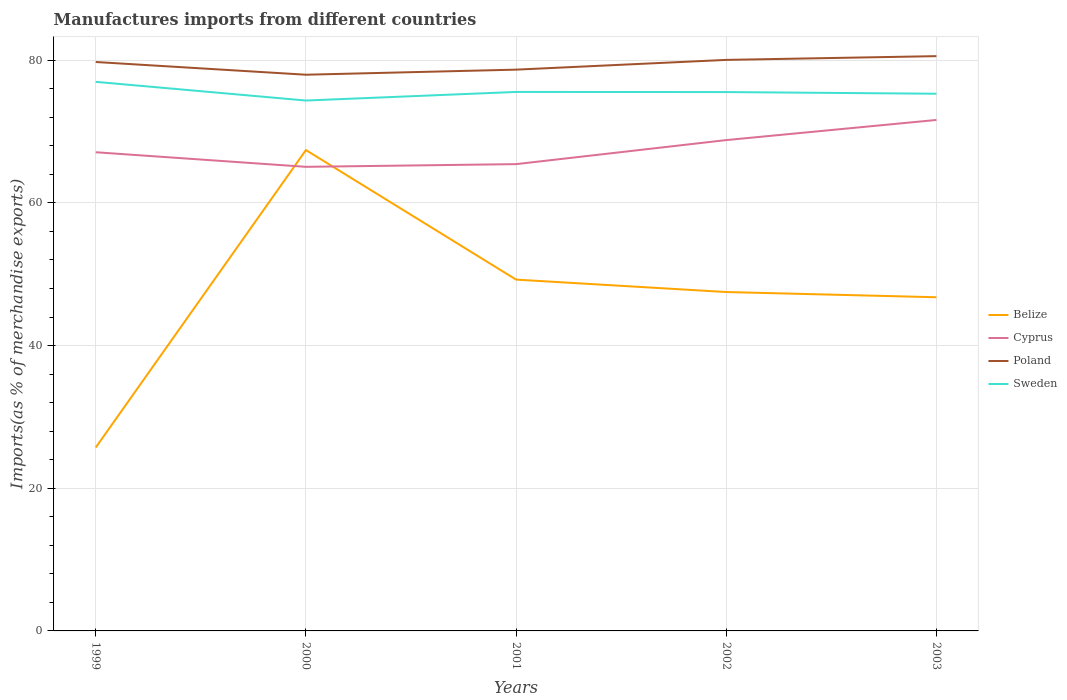Does the line corresponding to Cyprus intersect with the line corresponding to Poland?
Your response must be concise. No. Across all years, what is the maximum percentage of imports to different countries in Cyprus?
Give a very brief answer. 65.05. In which year was the percentage of imports to different countries in Belize maximum?
Your answer should be compact. 1999. What is the total percentage of imports to different countries in Cyprus in the graph?
Offer a terse response. -2.82. What is the difference between the highest and the second highest percentage of imports to different countries in Cyprus?
Your answer should be very brief. 6.57. What is the difference between the highest and the lowest percentage of imports to different countries in Belize?
Offer a very short reply. 3. Are the values on the major ticks of Y-axis written in scientific E-notation?
Make the answer very short. No. Does the graph contain any zero values?
Ensure brevity in your answer.  No. Does the graph contain grids?
Your answer should be compact. Yes. Where does the legend appear in the graph?
Provide a short and direct response. Center right. How are the legend labels stacked?
Offer a terse response. Vertical. What is the title of the graph?
Offer a very short reply. Manufactures imports from different countries. What is the label or title of the X-axis?
Your response must be concise. Years. What is the label or title of the Y-axis?
Make the answer very short. Imports(as % of merchandise exports). What is the Imports(as % of merchandise exports) in Belize in 1999?
Offer a very short reply. 25.71. What is the Imports(as % of merchandise exports) in Cyprus in 1999?
Give a very brief answer. 67.1. What is the Imports(as % of merchandise exports) in Poland in 1999?
Offer a very short reply. 79.74. What is the Imports(as % of merchandise exports) of Sweden in 1999?
Ensure brevity in your answer.  76.96. What is the Imports(as % of merchandise exports) of Belize in 2000?
Ensure brevity in your answer.  67.4. What is the Imports(as % of merchandise exports) of Cyprus in 2000?
Provide a succinct answer. 65.05. What is the Imports(as % of merchandise exports) of Poland in 2000?
Your answer should be very brief. 77.96. What is the Imports(as % of merchandise exports) of Sweden in 2000?
Your answer should be very brief. 74.34. What is the Imports(as % of merchandise exports) in Belize in 2001?
Your answer should be very brief. 49.24. What is the Imports(as % of merchandise exports) in Cyprus in 2001?
Provide a succinct answer. 65.43. What is the Imports(as % of merchandise exports) in Poland in 2001?
Ensure brevity in your answer.  78.67. What is the Imports(as % of merchandise exports) in Sweden in 2001?
Provide a succinct answer. 75.55. What is the Imports(as % of merchandise exports) of Belize in 2002?
Ensure brevity in your answer.  47.5. What is the Imports(as % of merchandise exports) in Cyprus in 2002?
Provide a short and direct response. 68.8. What is the Imports(as % of merchandise exports) of Poland in 2002?
Offer a very short reply. 80.04. What is the Imports(as % of merchandise exports) in Sweden in 2002?
Ensure brevity in your answer.  75.53. What is the Imports(as % of merchandise exports) of Belize in 2003?
Offer a very short reply. 46.77. What is the Imports(as % of merchandise exports) in Cyprus in 2003?
Provide a short and direct response. 71.62. What is the Imports(as % of merchandise exports) in Poland in 2003?
Your answer should be very brief. 80.57. What is the Imports(as % of merchandise exports) of Sweden in 2003?
Keep it short and to the point. 75.3. Across all years, what is the maximum Imports(as % of merchandise exports) in Belize?
Your response must be concise. 67.4. Across all years, what is the maximum Imports(as % of merchandise exports) of Cyprus?
Offer a terse response. 71.62. Across all years, what is the maximum Imports(as % of merchandise exports) of Poland?
Make the answer very short. 80.57. Across all years, what is the maximum Imports(as % of merchandise exports) of Sweden?
Your response must be concise. 76.96. Across all years, what is the minimum Imports(as % of merchandise exports) in Belize?
Your answer should be very brief. 25.71. Across all years, what is the minimum Imports(as % of merchandise exports) of Cyprus?
Your answer should be very brief. 65.05. Across all years, what is the minimum Imports(as % of merchandise exports) in Poland?
Provide a short and direct response. 77.96. Across all years, what is the minimum Imports(as % of merchandise exports) of Sweden?
Your response must be concise. 74.34. What is the total Imports(as % of merchandise exports) in Belize in the graph?
Your answer should be very brief. 236.63. What is the total Imports(as % of merchandise exports) of Cyprus in the graph?
Ensure brevity in your answer.  338. What is the total Imports(as % of merchandise exports) of Poland in the graph?
Your answer should be very brief. 396.98. What is the total Imports(as % of merchandise exports) in Sweden in the graph?
Offer a very short reply. 377.68. What is the difference between the Imports(as % of merchandise exports) of Belize in 1999 and that in 2000?
Provide a succinct answer. -41.69. What is the difference between the Imports(as % of merchandise exports) of Cyprus in 1999 and that in 2000?
Your response must be concise. 2.04. What is the difference between the Imports(as % of merchandise exports) of Poland in 1999 and that in 2000?
Your answer should be very brief. 1.78. What is the difference between the Imports(as % of merchandise exports) of Sweden in 1999 and that in 2000?
Offer a terse response. 2.62. What is the difference between the Imports(as % of merchandise exports) in Belize in 1999 and that in 2001?
Keep it short and to the point. -23.53. What is the difference between the Imports(as % of merchandise exports) in Cyprus in 1999 and that in 2001?
Your answer should be very brief. 1.67. What is the difference between the Imports(as % of merchandise exports) of Poland in 1999 and that in 2001?
Offer a very short reply. 1.07. What is the difference between the Imports(as % of merchandise exports) in Sweden in 1999 and that in 2001?
Offer a very short reply. 1.41. What is the difference between the Imports(as % of merchandise exports) of Belize in 1999 and that in 2002?
Make the answer very short. -21.79. What is the difference between the Imports(as % of merchandise exports) of Cyprus in 1999 and that in 2002?
Your answer should be very brief. -1.7. What is the difference between the Imports(as % of merchandise exports) in Poland in 1999 and that in 2002?
Give a very brief answer. -0.3. What is the difference between the Imports(as % of merchandise exports) in Sweden in 1999 and that in 2002?
Your response must be concise. 1.43. What is the difference between the Imports(as % of merchandise exports) in Belize in 1999 and that in 2003?
Ensure brevity in your answer.  -21.06. What is the difference between the Imports(as % of merchandise exports) in Cyprus in 1999 and that in 2003?
Your answer should be compact. -4.53. What is the difference between the Imports(as % of merchandise exports) of Poland in 1999 and that in 2003?
Your answer should be very brief. -0.82. What is the difference between the Imports(as % of merchandise exports) in Sweden in 1999 and that in 2003?
Make the answer very short. 1.67. What is the difference between the Imports(as % of merchandise exports) of Belize in 2000 and that in 2001?
Your response must be concise. 18.16. What is the difference between the Imports(as % of merchandise exports) of Cyprus in 2000 and that in 2001?
Offer a very short reply. -0.38. What is the difference between the Imports(as % of merchandise exports) in Poland in 2000 and that in 2001?
Your answer should be compact. -0.71. What is the difference between the Imports(as % of merchandise exports) in Sweden in 2000 and that in 2001?
Provide a succinct answer. -1.21. What is the difference between the Imports(as % of merchandise exports) in Belize in 2000 and that in 2002?
Your answer should be very brief. 19.9. What is the difference between the Imports(as % of merchandise exports) of Cyprus in 2000 and that in 2002?
Offer a very short reply. -3.75. What is the difference between the Imports(as % of merchandise exports) of Poland in 2000 and that in 2002?
Keep it short and to the point. -2.08. What is the difference between the Imports(as % of merchandise exports) in Sweden in 2000 and that in 2002?
Provide a short and direct response. -1.19. What is the difference between the Imports(as % of merchandise exports) in Belize in 2000 and that in 2003?
Give a very brief answer. 20.63. What is the difference between the Imports(as % of merchandise exports) in Cyprus in 2000 and that in 2003?
Ensure brevity in your answer.  -6.57. What is the difference between the Imports(as % of merchandise exports) in Poland in 2000 and that in 2003?
Give a very brief answer. -2.6. What is the difference between the Imports(as % of merchandise exports) of Sweden in 2000 and that in 2003?
Your answer should be very brief. -0.95. What is the difference between the Imports(as % of merchandise exports) in Belize in 2001 and that in 2002?
Ensure brevity in your answer.  1.74. What is the difference between the Imports(as % of merchandise exports) in Cyprus in 2001 and that in 2002?
Provide a short and direct response. -3.37. What is the difference between the Imports(as % of merchandise exports) in Poland in 2001 and that in 2002?
Keep it short and to the point. -1.37. What is the difference between the Imports(as % of merchandise exports) of Sweden in 2001 and that in 2002?
Provide a succinct answer. 0.02. What is the difference between the Imports(as % of merchandise exports) in Belize in 2001 and that in 2003?
Keep it short and to the point. 2.47. What is the difference between the Imports(as % of merchandise exports) of Cyprus in 2001 and that in 2003?
Ensure brevity in your answer.  -6.19. What is the difference between the Imports(as % of merchandise exports) of Poland in 2001 and that in 2003?
Your answer should be very brief. -1.89. What is the difference between the Imports(as % of merchandise exports) in Sweden in 2001 and that in 2003?
Keep it short and to the point. 0.25. What is the difference between the Imports(as % of merchandise exports) of Belize in 2002 and that in 2003?
Your answer should be very brief. 0.73. What is the difference between the Imports(as % of merchandise exports) of Cyprus in 2002 and that in 2003?
Provide a succinct answer. -2.82. What is the difference between the Imports(as % of merchandise exports) of Poland in 2002 and that in 2003?
Your answer should be very brief. -0.53. What is the difference between the Imports(as % of merchandise exports) in Sweden in 2002 and that in 2003?
Offer a very short reply. 0.24. What is the difference between the Imports(as % of merchandise exports) in Belize in 1999 and the Imports(as % of merchandise exports) in Cyprus in 2000?
Offer a very short reply. -39.34. What is the difference between the Imports(as % of merchandise exports) of Belize in 1999 and the Imports(as % of merchandise exports) of Poland in 2000?
Offer a very short reply. -52.25. What is the difference between the Imports(as % of merchandise exports) of Belize in 1999 and the Imports(as % of merchandise exports) of Sweden in 2000?
Keep it short and to the point. -48.63. What is the difference between the Imports(as % of merchandise exports) of Cyprus in 1999 and the Imports(as % of merchandise exports) of Poland in 2000?
Provide a succinct answer. -10.87. What is the difference between the Imports(as % of merchandise exports) in Cyprus in 1999 and the Imports(as % of merchandise exports) in Sweden in 2000?
Your answer should be compact. -7.25. What is the difference between the Imports(as % of merchandise exports) of Poland in 1999 and the Imports(as % of merchandise exports) of Sweden in 2000?
Keep it short and to the point. 5.4. What is the difference between the Imports(as % of merchandise exports) in Belize in 1999 and the Imports(as % of merchandise exports) in Cyprus in 2001?
Give a very brief answer. -39.72. What is the difference between the Imports(as % of merchandise exports) of Belize in 1999 and the Imports(as % of merchandise exports) of Poland in 2001?
Your response must be concise. -52.96. What is the difference between the Imports(as % of merchandise exports) of Belize in 1999 and the Imports(as % of merchandise exports) of Sweden in 2001?
Provide a succinct answer. -49.84. What is the difference between the Imports(as % of merchandise exports) of Cyprus in 1999 and the Imports(as % of merchandise exports) of Poland in 2001?
Keep it short and to the point. -11.58. What is the difference between the Imports(as % of merchandise exports) of Cyprus in 1999 and the Imports(as % of merchandise exports) of Sweden in 2001?
Offer a terse response. -8.45. What is the difference between the Imports(as % of merchandise exports) in Poland in 1999 and the Imports(as % of merchandise exports) in Sweden in 2001?
Your answer should be very brief. 4.2. What is the difference between the Imports(as % of merchandise exports) in Belize in 1999 and the Imports(as % of merchandise exports) in Cyprus in 2002?
Provide a short and direct response. -43.09. What is the difference between the Imports(as % of merchandise exports) of Belize in 1999 and the Imports(as % of merchandise exports) of Poland in 2002?
Give a very brief answer. -54.33. What is the difference between the Imports(as % of merchandise exports) in Belize in 1999 and the Imports(as % of merchandise exports) in Sweden in 2002?
Make the answer very short. -49.82. What is the difference between the Imports(as % of merchandise exports) of Cyprus in 1999 and the Imports(as % of merchandise exports) of Poland in 2002?
Offer a very short reply. -12.94. What is the difference between the Imports(as % of merchandise exports) in Cyprus in 1999 and the Imports(as % of merchandise exports) in Sweden in 2002?
Provide a short and direct response. -8.44. What is the difference between the Imports(as % of merchandise exports) in Poland in 1999 and the Imports(as % of merchandise exports) in Sweden in 2002?
Offer a very short reply. 4.21. What is the difference between the Imports(as % of merchandise exports) of Belize in 1999 and the Imports(as % of merchandise exports) of Cyprus in 2003?
Offer a terse response. -45.91. What is the difference between the Imports(as % of merchandise exports) of Belize in 1999 and the Imports(as % of merchandise exports) of Poland in 2003?
Provide a succinct answer. -54.85. What is the difference between the Imports(as % of merchandise exports) of Belize in 1999 and the Imports(as % of merchandise exports) of Sweden in 2003?
Provide a short and direct response. -49.58. What is the difference between the Imports(as % of merchandise exports) of Cyprus in 1999 and the Imports(as % of merchandise exports) of Poland in 2003?
Offer a very short reply. -13.47. What is the difference between the Imports(as % of merchandise exports) of Cyprus in 1999 and the Imports(as % of merchandise exports) of Sweden in 2003?
Your response must be concise. -8.2. What is the difference between the Imports(as % of merchandise exports) of Poland in 1999 and the Imports(as % of merchandise exports) of Sweden in 2003?
Offer a terse response. 4.45. What is the difference between the Imports(as % of merchandise exports) in Belize in 2000 and the Imports(as % of merchandise exports) in Cyprus in 2001?
Your answer should be compact. 1.97. What is the difference between the Imports(as % of merchandise exports) of Belize in 2000 and the Imports(as % of merchandise exports) of Poland in 2001?
Offer a terse response. -11.27. What is the difference between the Imports(as % of merchandise exports) in Belize in 2000 and the Imports(as % of merchandise exports) in Sweden in 2001?
Your response must be concise. -8.15. What is the difference between the Imports(as % of merchandise exports) in Cyprus in 2000 and the Imports(as % of merchandise exports) in Poland in 2001?
Give a very brief answer. -13.62. What is the difference between the Imports(as % of merchandise exports) of Cyprus in 2000 and the Imports(as % of merchandise exports) of Sweden in 2001?
Your response must be concise. -10.5. What is the difference between the Imports(as % of merchandise exports) of Poland in 2000 and the Imports(as % of merchandise exports) of Sweden in 2001?
Your answer should be very brief. 2.41. What is the difference between the Imports(as % of merchandise exports) of Belize in 2000 and the Imports(as % of merchandise exports) of Cyprus in 2002?
Provide a succinct answer. -1.4. What is the difference between the Imports(as % of merchandise exports) of Belize in 2000 and the Imports(as % of merchandise exports) of Poland in 2002?
Offer a very short reply. -12.64. What is the difference between the Imports(as % of merchandise exports) in Belize in 2000 and the Imports(as % of merchandise exports) in Sweden in 2002?
Offer a very short reply. -8.13. What is the difference between the Imports(as % of merchandise exports) of Cyprus in 2000 and the Imports(as % of merchandise exports) of Poland in 2002?
Provide a succinct answer. -14.99. What is the difference between the Imports(as % of merchandise exports) of Cyprus in 2000 and the Imports(as % of merchandise exports) of Sweden in 2002?
Give a very brief answer. -10.48. What is the difference between the Imports(as % of merchandise exports) of Poland in 2000 and the Imports(as % of merchandise exports) of Sweden in 2002?
Offer a terse response. 2.43. What is the difference between the Imports(as % of merchandise exports) in Belize in 2000 and the Imports(as % of merchandise exports) in Cyprus in 2003?
Make the answer very short. -4.22. What is the difference between the Imports(as % of merchandise exports) in Belize in 2000 and the Imports(as % of merchandise exports) in Poland in 2003?
Ensure brevity in your answer.  -13.16. What is the difference between the Imports(as % of merchandise exports) in Belize in 2000 and the Imports(as % of merchandise exports) in Sweden in 2003?
Offer a terse response. -7.89. What is the difference between the Imports(as % of merchandise exports) of Cyprus in 2000 and the Imports(as % of merchandise exports) of Poland in 2003?
Your answer should be compact. -15.51. What is the difference between the Imports(as % of merchandise exports) in Cyprus in 2000 and the Imports(as % of merchandise exports) in Sweden in 2003?
Ensure brevity in your answer.  -10.24. What is the difference between the Imports(as % of merchandise exports) in Poland in 2000 and the Imports(as % of merchandise exports) in Sweden in 2003?
Offer a very short reply. 2.67. What is the difference between the Imports(as % of merchandise exports) of Belize in 2001 and the Imports(as % of merchandise exports) of Cyprus in 2002?
Your response must be concise. -19.56. What is the difference between the Imports(as % of merchandise exports) in Belize in 2001 and the Imports(as % of merchandise exports) in Poland in 2002?
Keep it short and to the point. -30.8. What is the difference between the Imports(as % of merchandise exports) in Belize in 2001 and the Imports(as % of merchandise exports) in Sweden in 2002?
Ensure brevity in your answer.  -26.29. What is the difference between the Imports(as % of merchandise exports) in Cyprus in 2001 and the Imports(as % of merchandise exports) in Poland in 2002?
Keep it short and to the point. -14.61. What is the difference between the Imports(as % of merchandise exports) in Cyprus in 2001 and the Imports(as % of merchandise exports) in Sweden in 2002?
Provide a succinct answer. -10.1. What is the difference between the Imports(as % of merchandise exports) of Poland in 2001 and the Imports(as % of merchandise exports) of Sweden in 2002?
Your answer should be very brief. 3.14. What is the difference between the Imports(as % of merchandise exports) in Belize in 2001 and the Imports(as % of merchandise exports) in Cyprus in 2003?
Offer a terse response. -22.38. What is the difference between the Imports(as % of merchandise exports) in Belize in 2001 and the Imports(as % of merchandise exports) in Poland in 2003?
Offer a very short reply. -31.32. What is the difference between the Imports(as % of merchandise exports) in Belize in 2001 and the Imports(as % of merchandise exports) in Sweden in 2003?
Offer a terse response. -26.05. What is the difference between the Imports(as % of merchandise exports) in Cyprus in 2001 and the Imports(as % of merchandise exports) in Poland in 2003?
Your answer should be compact. -15.14. What is the difference between the Imports(as % of merchandise exports) in Cyprus in 2001 and the Imports(as % of merchandise exports) in Sweden in 2003?
Provide a succinct answer. -9.87. What is the difference between the Imports(as % of merchandise exports) in Poland in 2001 and the Imports(as % of merchandise exports) in Sweden in 2003?
Your answer should be compact. 3.38. What is the difference between the Imports(as % of merchandise exports) in Belize in 2002 and the Imports(as % of merchandise exports) in Cyprus in 2003?
Provide a short and direct response. -24.12. What is the difference between the Imports(as % of merchandise exports) of Belize in 2002 and the Imports(as % of merchandise exports) of Poland in 2003?
Your response must be concise. -33.06. What is the difference between the Imports(as % of merchandise exports) of Belize in 2002 and the Imports(as % of merchandise exports) of Sweden in 2003?
Your answer should be very brief. -27.8. What is the difference between the Imports(as % of merchandise exports) of Cyprus in 2002 and the Imports(as % of merchandise exports) of Poland in 2003?
Your answer should be compact. -11.77. What is the difference between the Imports(as % of merchandise exports) in Cyprus in 2002 and the Imports(as % of merchandise exports) in Sweden in 2003?
Offer a terse response. -6.5. What is the difference between the Imports(as % of merchandise exports) in Poland in 2002 and the Imports(as % of merchandise exports) in Sweden in 2003?
Provide a short and direct response. 4.74. What is the average Imports(as % of merchandise exports) of Belize per year?
Give a very brief answer. 47.33. What is the average Imports(as % of merchandise exports) of Cyprus per year?
Your answer should be very brief. 67.6. What is the average Imports(as % of merchandise exports) of Poland per year?
Give a very brief answer. 79.4. What is the average Imports(as % of merchandise exports) in Sweden per year?
Provide a short and direct response. 75.54. In the year 1999, what is the difference between the Imports(as % of merchandise exports) of Belize and Imports(as % of merchandise exports) of Cyprus?
Make the answer very short. -41.38. In the year 1999, what is the difference between the Imports(as % of merchandise exports) in Belize and Imports(as % of merchandise exports) in Poland?
Provide a short and direct response. -54.03. In the year 1999, what is the difference between the Imports(as % of merchandise exports) of Belize and Imports(as % of merchandise exports) of Sweden?
Your response must be concise. -51.25. In the year 1999, what is the difference between the Imports(as % of merchandise exports) of Cyprus and Imports(as % of merchandise exports) of Poland?
Your answer should be compact. -12.65. In the year 1999, what is the difference between the Imports(as % of merchandise exports) in Cyprus and Imports(as % of merchandise exports) in Sweden?
Provide a short and direct response. -9.87. In the year 1999, what is the difference between the Imports(as % of merchandise exports) of Poland and Imports(as % of merchandise exports) of Sweden?
Keep it short and to the point. 2.78. In the year 2000, what is the difference between the Imports(as % of merchandise exports) in Belize and Imports(as % of merchandise exports) in Cyprus?
Your answer should be compact. 2.35. In the year 2000, what is the difference between the Imports(as % of merchandise exports) of Belize and Imports(as % of merchandise exports) of Poland?
Make the answer very short. -10.56. In the year 2000, what is the difference between the Imports(as % of merchandise exports) of Belize and Imports(as % of merchandise exports) of Sweden?
Offer a terse response. -6.94. In the year 2000, what is the difference between the Imports(as % of merchandise exports) of Cyprus and Imports(as % of merchandise exports) of Poland?
Keep it short and to the point. -12.91. In the year 2000, what is the difference between the Imports(as % of merchandise exports) in Cyprus and Imports(as % of merchandise exports) in Sweden?
Offer a terse response. -9.29. In the year 2000, what is the difference between the Imports(as % of merchandise exports) of Poland and Imports(as % of merchandise exports) of Sweden?
Give a very brief answer. 3.62. In the year 2001, what is the difference between the Imports(as % of merchandise exports) in Belize and Imports(as % of merchandise exports) in Cyprus?
Your answer should be very brief. -16.19. In the year 2001, what is the difference between the Imports(as % of merchandise exports) in Belize and Imports(as % of merchandise exports) in Poland?
Offer a terse response. -29.43. In the year 2001, what is the difference between the Imports(as % of merchandise exports) of Belize and Imports(as % of merchandise exports) of Sweden?
Keep it short and to the point. -26.31. In the year 2001, what is the difference between the Imports(as % of merchandise exports) in Cyprus and Imports(as % of merchandise exports) in Poland?
Ensure brevity in your answer.  -13.24. In the year 2001, what is the difference between the Imports(as % of merchandise exports) of Cyprus and Imports(as % of merchandise exports) of Sweden?
Your answer should be very brief. -10.12. In the year 2001, what is the difference between the Imports(as % of merchandise exports) in Poland and Imports(as % of merchandise exports) in Sweden?
Ensure brevity in your answer.  3.12. In the year 2002, what is the difference between the Imports(as % of merchandise exports) in Belize and Imports(as % of merchandise exports) in Cyprus?
Your answer should be compact. -21.3. In the year 2002, what is the difference between the Imports(as % of merchandise exports) in Belize and Imports(as % of merchandise exports) in Poland?
Offer a very short reply. -32.54. In the year 2002, what is the difference between the Imports(as % of merchandise exports) of Belize and Imports(as % of merchandise exports) of Sweden?
Offer a terse response. -28.03. In the year 2002, what is the difference between the Imports(as % of merchandise exports) of Cyprus and Imports(as % of merchandise exports) of Poland?
Give a very brief answer. -11.24. In the year 2002, what is the difference between the Imports(as % of merchandise exports) in Cyprus and Imports(as % of merchandise exports) in Sweden?
Offer a very short reply. -6.73. In the year 2002, what is the difference between the Imports(as % of merchandise exports) in Poland and Imports(as % of merchandise exports) in Sweden?
Provide a short and direct response. 4.51. In the year 2003, what is the difference between the Imports(as % of merchandise exports) in Belize and Imports(as % of merchandise exports) in Cyprus?
Your response must be concise. -24.85. In the year 2003, what is the difference between the Imports(as % of merchandise exports) of Belize and Imports(as % of merchandise exports) of Poland?
Ensure brevity in your answer.  -33.8. In the year 2003, what is the difference between the Imports(as % of merchandise exports) of Belize and Imports(as % of merchandise exports) of Sweden?
Your answer should be very brief. -28.53. In the year 2003, what is the difference between the Imports(as % of merchandise exports) in Cyprus and Imports(as % of merchandise exports) in Poland?
Give a very brief answer. -8.94. In the year 2003, what is the difference between the Imports(as % of merchandise exports) of Cyprus and Imports(as % of merchandise exports) of Sweden?
Your answer should be compact. -3.67. In the year 2003, what is the difference between the Imports(as % of merchandise exports) in Poland and Imports(as % of merchandise exports) in Sweden?
Make the answer very short. 5.27. What is the ratio of the Imports(as % of merchandise exports) in Belize in 1999 to that in 2000?
Your answer should be compact. 0.38. What is the ratio of the Imports(as % of merchandise exports) in Cyprus in 1999 to that in 2000?
Keep it short and to the point. 1.03. What is the ratio of the Imports(as % of merchandise exports) in Poland in 1999 to that in 2000?
Give a very brief answer. 1.02. What is the ratio of the Imports(as % of merchandise exports) of Sweden in 1999 to that in 2000?
Give a very brief answer. 1.04. What is the ratio of the Imports(as % of merchandise exports) in Belize in 1999 to that in 2001?
Your answer should be very brief. 0.52. What is the ratio of the Imports(as % of merchandise exports) in Cyprus in 1999 to that in 2001?
Your response must be concise. 1.03. What is the ratio of the Imports(as % of merchandise exports) in Poland in 1999 to that in 2001?
Ensure brevity in your answer.  1.01. What is the ratio of the Imports(as % of merchandise exports) in Sweden in 1999 to that in 2001?
Give a very brief answer. 1.02. What is the ratio of the Imports(as % of merchandise exports) of Belize in 1999 to that in 2002?
Ensure brevity in your answer.  0.54. What is the ratio of the Imports(as % of merchandise exports) in Cyprus in 1999 to that in 2002?
Offer a terse response. 0.98. What is the ratio of the Imports(as % of merchandise exports) of Belize in 1999 to that in 2003?
Give a very brief answer. 0.55. What is the ratio of the Imports(as % of merchandise exports) in Cyprus in 1999 to that in 2003?
Provide a short and direct response. 0.94. What is the ratio of the Imports(as % of merchandise exports) in Sweden in 1999 to that in 2003?
Keep it short and to the point. 1.02. What is the ratio of the Imports(as % of merchandise exports) in Belize in 2000 to that in 2001?
Make the answer very short. 1.37. What is the ratio of the Imports(as % of merchandise exports) in Cyprus in 2000 to that in 2001?
Offer a very short reply. 0.99. What is the ratio of the Imports(as % of merchandise exports) of Belize in 2000 to that in 2002?
Provide a short and direct response. 1.42. What is the ratio of the Imports(as % of merchandise exports) of Cyprus in 2000 to that in 2002?
Give a very brief answer. 0.95. What is the ratio of the Imports(as % of merchandise exports) in Poland in 2000 to that in 2002?
Your answer should be compact. 0.97. What is the ratio of the Imports(as % of merchandise exports) of Sweden in 2000 to that in 2002?
Give a very brief answer. 0.98. What is the ratio of the Imports(as % of merchandise exports) in Belize in 2000 to that in 2003?
Provide a short and direct response. 1.44. What is the ratio of the Imports(as % of merchandise exports) of Cyprus in 2000 to that in 2003?
Your response must be concise. 0.91. What is the ratio of the Imports(as % of merchandise exports) in Poland in 2000 to that in 2003?
Keep it short and to the point. 0.97. What is the ratio of the Imports(as % of merchandise exports) in Sweden in 2000 to that in 2003?
Provide a succinct answer. 0.99. What is the ratio of the Imports(as % of merchandise exports) of Belize in 2001 to that in 2002?
Provide a short and direct response. 1.04. What is the ratio of the Imports(as % of merchandise exports) in Cyprus in 2001 to that in 2002?
Make the answer very short. 0.95. What is the ratio of the Imports(as % of merchandise exports) of Poland in 2001 to that in 2002?
Offer a very short reply. 0.98. What is the ratio of the Imports(as % of merchandise exports) of Belize in 2001 to that in 2003?
Keep it short and to the point. 1.05. What is the ratio of the Imports(as % of merchandise exports) of Cyprus in 2001 to that in 2003?
Provide a short and direct response. 0.91. What is the ratio of the Imports(as % of merchandise exports) of Poland in 2001 to that in 2003?
Your answer should be compact. 0.98. What is the ratio of the Imports(as % of merchandise exports) of Belize in 2002 to that in 2003?
Offer a terse response. 1.02. What is the ratio of the Imports(as % of merchandise exports) of Cyprus in 2002 to that in 2003?
Your answer should be compact. 0.96. What is the ratio of the Imports(as % of merchandise exports) of Poland in 2002 to that in 2003?
Your response must be concise. 0.99. What is the ratio of the Imports(as % of merchandise exports) in Sweden in 2002 to that in 2003?
Keep it short and to the point. 1. What is the difference between the highest and the second highest Imports(as % of merchandise exports) in Belize?
Provide a succinct answer. 18.16. What is the difference between the highest and the second highest Imports(as % of merchandise exports) in Cyprus?
Ensure brevity in your answer.  2.82. What is the difference between the highest and the second highest Imports(as % of merchandise exports) in Poland?
Provide a short and direct response. 0.53. What is the difference between the highest and the second highest Imports(as % of merchandise exports) of Sweden?
Your answer should be very brief. 1.41. What is the difference between the highest and the lowest Imports(as % of merchandise exports) of Belize?
Keep it short and to the point. 41.69. What is the difference between the highest and the lowest Imports(as % of merchandise exports) in Cyprus?
Your response must be concise. 6.57. What is the difference between the highest and the lowest Imports(as % of merchandise exports) in Poland?
Ensure brevity in your answer.  2.6. What is the difference between the highest and the lowest Imports(as % of merchandise exports) of Sweden?
Offer a terse response. 2.62. 